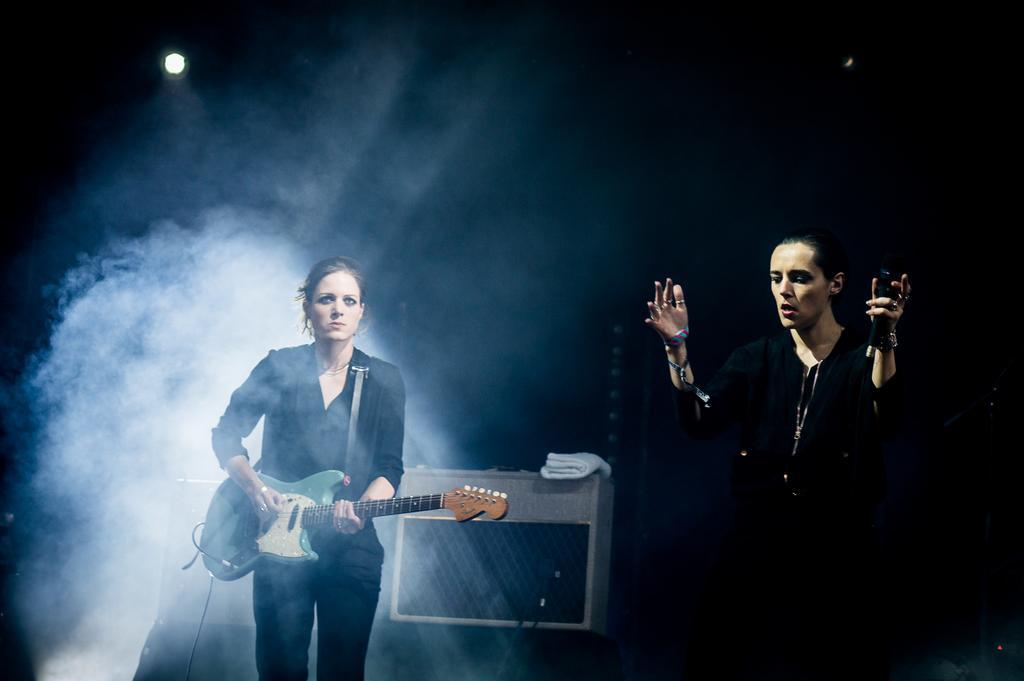How would you summarize this image in a sentence or two? In this image we can see two lady persons wearing black color dress standing, one of the person playing guitar and the other is holding microphone in her hands and in the background of the image there is a sound box and a light. 